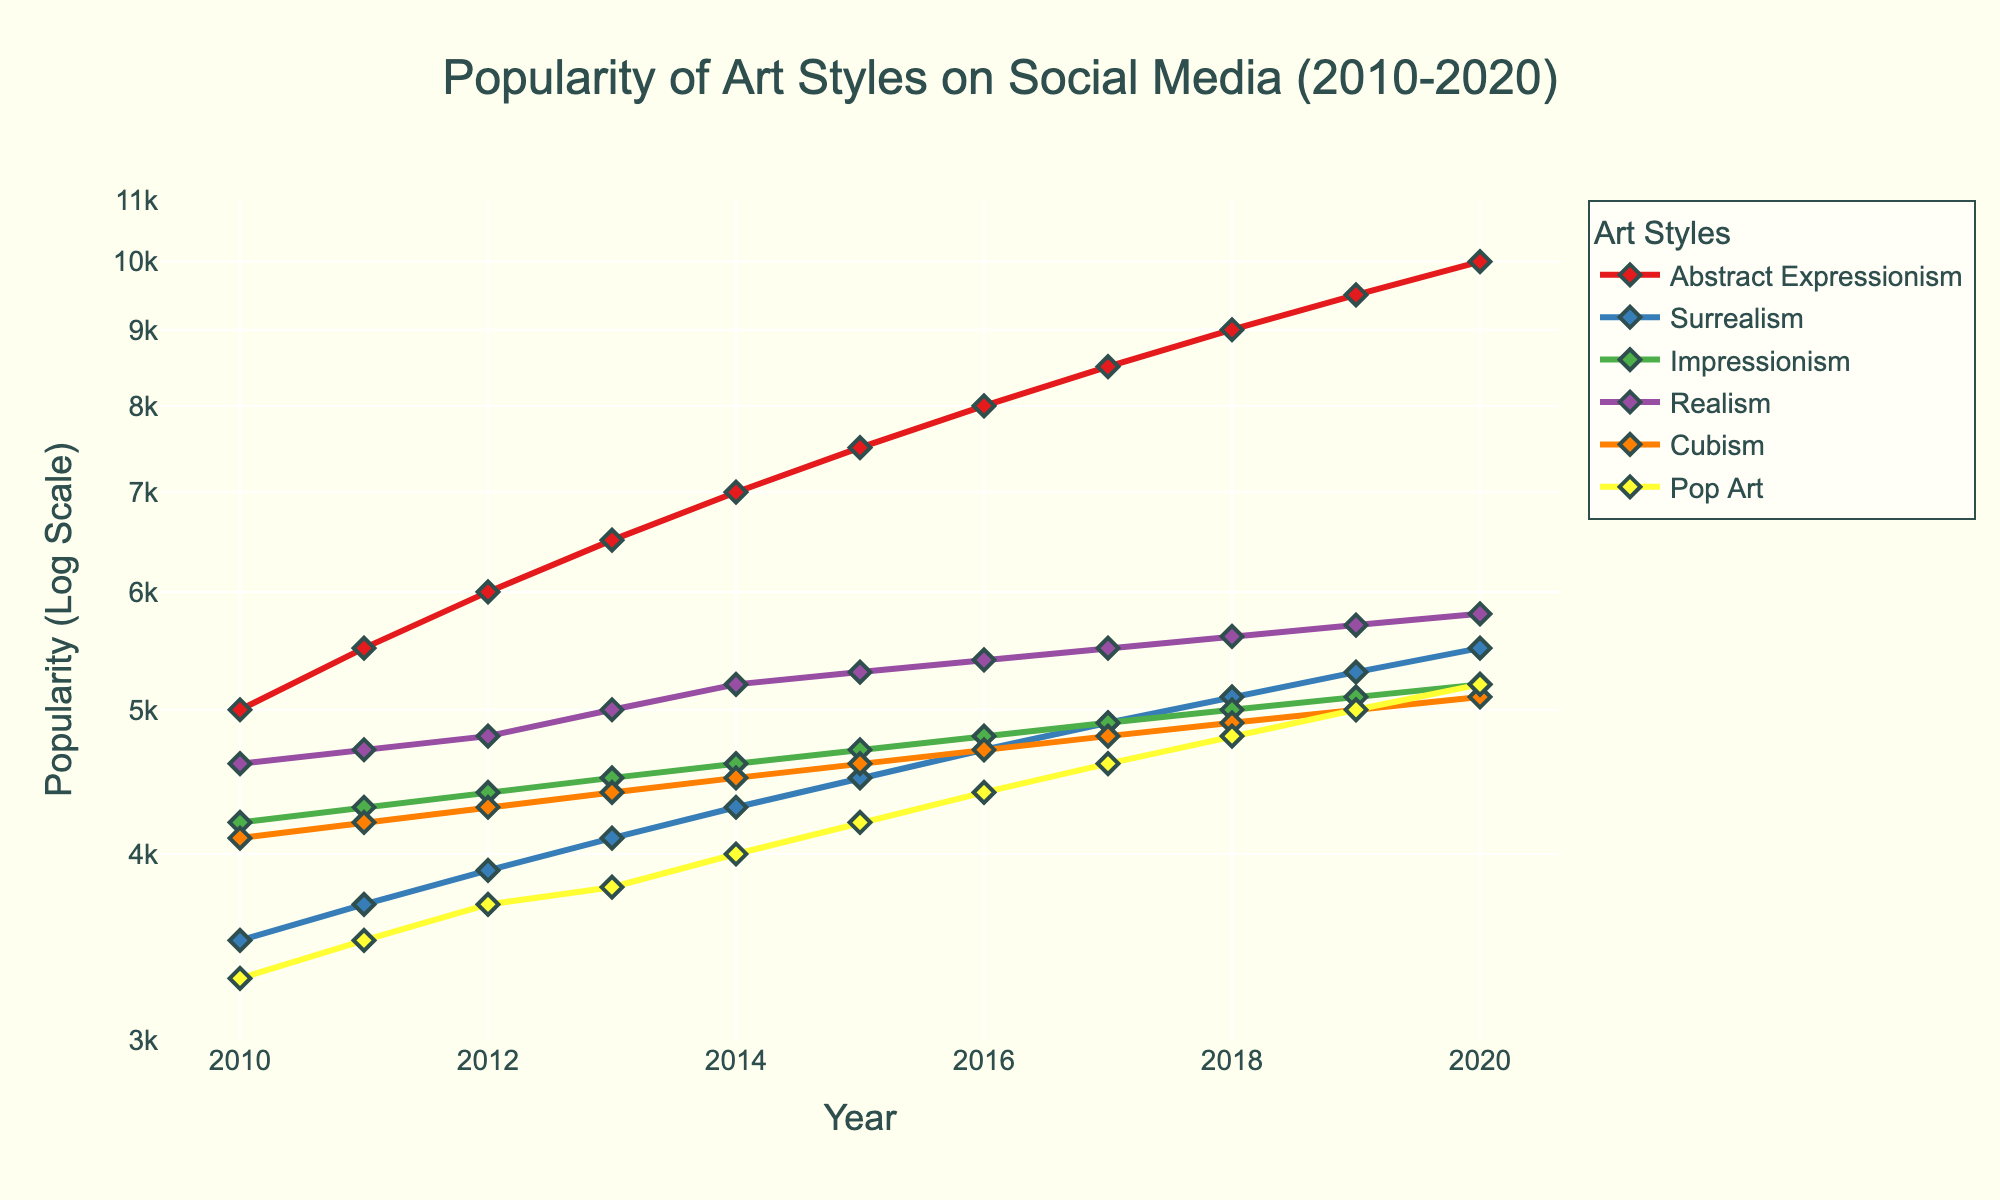What is the title of the figure? The title is located at the top center of the figure in a larger font size, and it reads "Popularity of Art Styles on Social Media (2010-2020)".
Answer: Popularity of Art Styles on Social Media (2010-2020) Which art style had the highest popularity in 2016? By examining the y-axis values for the year 2016, Abstract Expressionism has the highest value compared to other art styles.
Answer: Abstract Expressionism What is the y-axis label of the plot? The y-axis label can be found on the left vertical axis and reads "Popularity (Log Scale)".
Answer: Popularity (Log Scale) How did the popularity of Surrealism change from 2010 to 2020? By comparing the y-axis values for Surrealism in 2010 (3500) and 2020 (5500), we can see that the popularity increased over the decade.
Answer: Increased Which art style showed the least increase in popularity from 2010 to 2020? To find the smallest increase, we need to calculate the differences for each art style and compare them. Realism increased from 4600 to 5800, a difference of 1200, which is the smallest among all.
Answer: Realism How does the popularity of Pop Art in 2020 compare to that of Cubism in 2010? Pop Art in 2020 has a popularity of 5200, while Cubism in 2010 has a popularity of 4100. Pop Art is thus more popular in 2020 compared to Cubism in 2010.
Answer: More popular Which two art styles had the closest popularity values in 2017? By inspecting the values, Impressionism and Surrealism both have values close to 4900 in 2017, making them very close in popularity.
Answer: Impressionism and Surrealism In which year did Realism first exceed 5000 in popularity? By observing the data for Realism, Realism surpassed 5000 for the first time in 2013.
Answer: 2013 What is the general trend observed for the popularity of Abstract Expressionism from 2010 to 2020? From 2010 to 2020, Abstract Expressionism shows an upward trend, increasing steadily year by year.
Answer: Increasing If you were to predict the popularity of Cubism for the year 2021 based on the trend, what would it be? By observing the linear progression, Cubism increased approximately 100 units each year since 2013. Extrapolating this, the 2021 value would likely be around 5200, adding another 100 units to the 2020 value.
Answer: Around 5200 